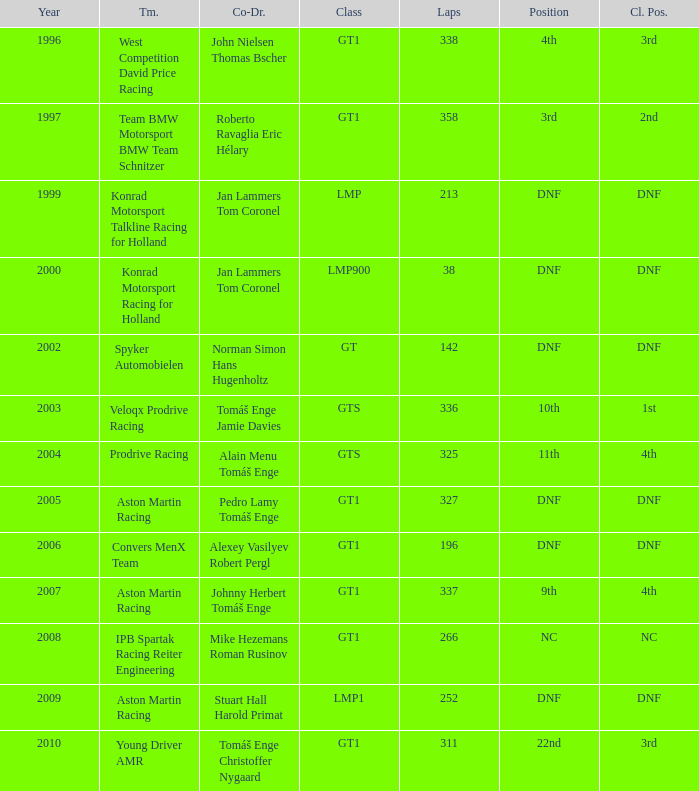Which team finished 3rd in class with 337 laps before 2008? West Competition David Price Racing. 